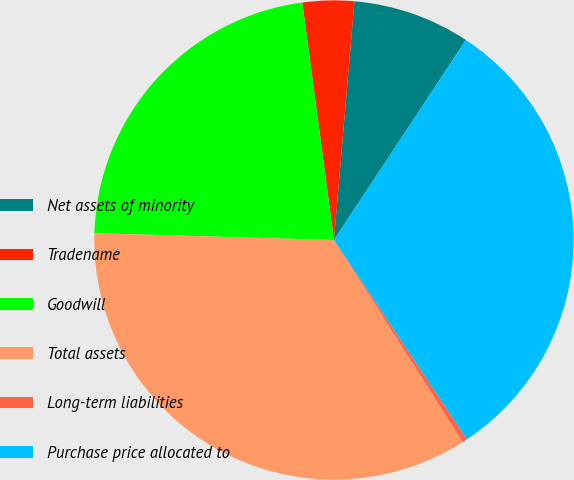<chart> <loc_0><loc_0><loc_500><loc_500><pie_chart><fcel>Net assets of minority<fcel>Tradename<fcel>Goodwill<fcel>Total assets<fcel>Long-term liabilities<fcel>Purchase price allocated to<nl><fcel>7.92%<fcel>3.47%<fcel>22.44%<fcel>34.49%<fcel>0.33%<fcel>31.35%<nl></chart> 